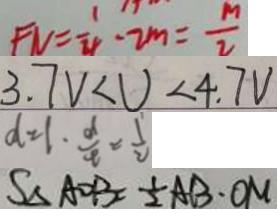<formula> <loc_0><loc_0><loc_500><loc_500>F N = \frac { 1 } { 4 } - 2 m = \frac { m } { 2 } 
 3 . 7 V < U < 4 . 7 V 
 d = 1 . \frac { d } { t } = \frac { 1 } { 2 } 
 S _ { \Delta A O B } = \frac { 1 } { 2 } A B \cdot O M</formula> 